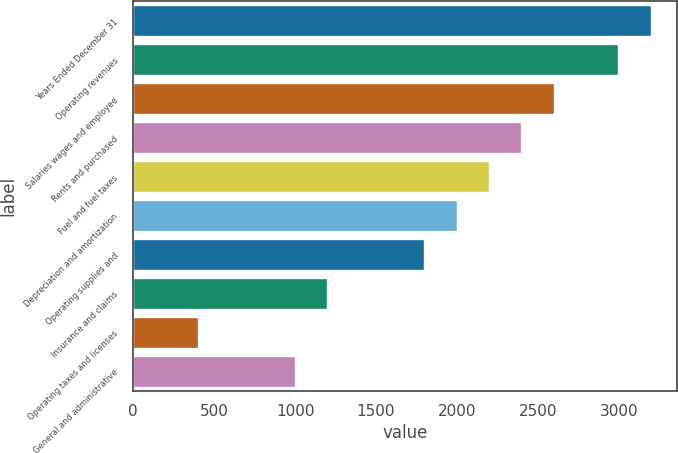Convert chart to OTSL. <chart><loc_0><loc_0><loc_500><loc_500><bar_chart><fcel>Years Ended December 31<fcel>Operating revenues<fcel>Salaries wages and employee<fcel>Rents and purchased<fcel>Fuel and fuel taxes<fcel>Depreciation and amortization<fcel>Operating supplies and<fcel>Insurance and claims<fcel>Operating taxes and licenses<fcel>General and administrative<nl><fcel>3197.92<fcel>2998.1<fcel>2598.46<fcel>2398.64<fcel>2198.82<fcel>1999<fcel>1799.18<fcel>1199.72<fcel>400.44<fcel>999.9<nl></chart> 